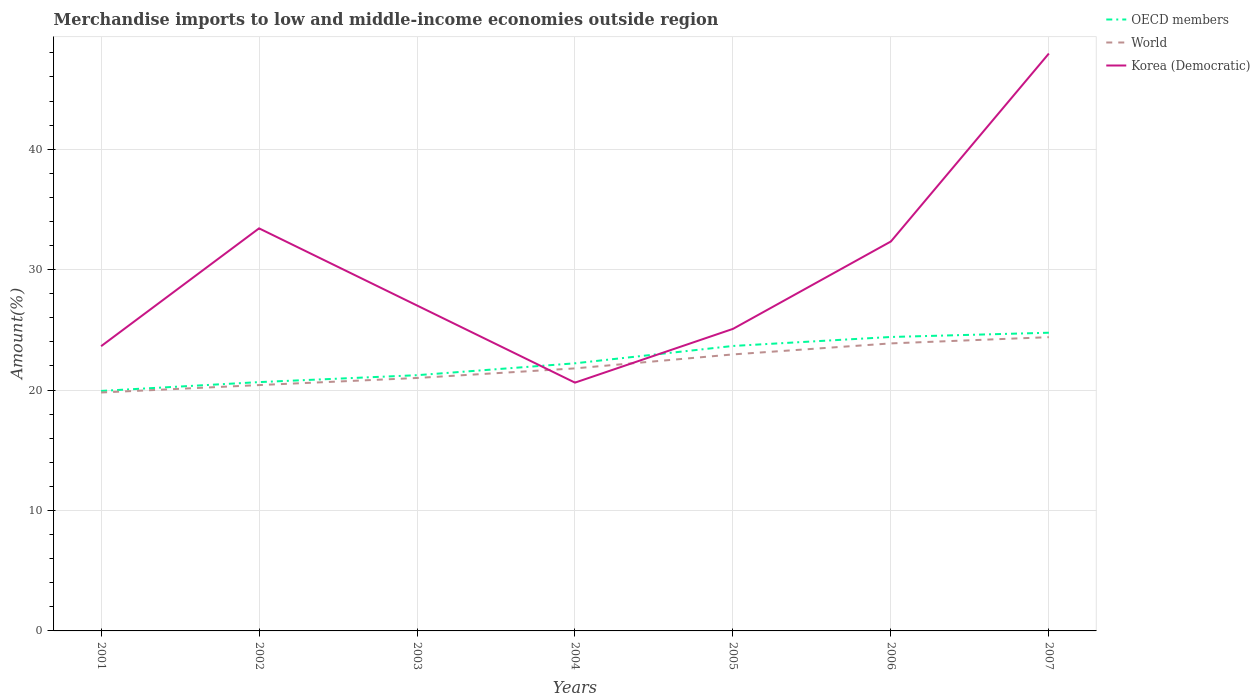How many different coloured lines are there?
Ensure brevity in your answer.  3. Across all years, what is the maximum percentage of amount earned from merchandise imports in World?
Provide a short and direct response. 19.8. In which year was the percentage of amount earned from merchandise imports in World maximum?
Ensure brevity in your answer.  2001. What is the total percentage of amount earned from merchandise imports in World in the graph?
Provide a short and direct response. -2.08. What is the difference between the highest and the second highest percentage of amount earned from merchandise imports in World?
Your response must be concise. 4.59. How many lines are there?
Your answer should be very brief. 3. What is the difference between two consecutive major ticks on the Y-axis?
Your answer should be compact. 10. Does the graph contain grids?
Provide a short and direct response. Yes. How are the legend labels stacked?
Give a very brief answer. Vertical. What is the title of the graph?
Your answer should be compact. Merchandise imports to low and middle-income economies outside region. Does "Palau" appear as one of the legend labels in the graph?
Offer a very short reply. No. What is the label or title of the X-axis?
Your response must be concise. Years. What is the label or title of the Y-axis?
Provide a succinct answer. Amount(%). What is the Amount(%) of OECD members in 2001?
Your response must be concise. 19.93. What is the Amount(%) of World in 2001?
Offer a very short reply. 19.8. What is the Amount(%) of Korea (Democratic) in 2001?
Offer a terse response. 23.64. What is the Amount(%) in OECD members in 2002?
Offer a very short reply. 20.66. What is the Amount(%) in World in 2002?
Offer a very short reply. 20.41. What is the Amount(%) of Korea (Democratic) in 2002?
Provide a succinct answer. 33.43. What is the Amount(%) of OECD members in 2003?
Your answer should be very brief. 21.23. What is the Amount(%) in World in 2003?
Your answer should be very brief. 21. What is the Amount(%) in Korea (Democratic) in 2003?
Offer a terse response. 27.02. What is the Amount(%) in OECD members in 2004?
Your answer should be compact. 22.22. What is the Amount(%) of World in 2004?
Make the answer very short. 21.8. What is the Amount(%) of Korea (Democratic) in 2004?
Give a very brief answer. 20.62. What is the Amount(%) of OECD members in 2005?
Keep it short and to the point. 23.66. What is the Amount(%) in World in 2005?
Your answer should be very brief. 22.96. What is the Amount(%) of Korea (Democratic) in 2005?
Keep it short and to the point. 25.08. What is the Amount(%) of OECD members in 2006?
Provide a succinct answer. 24.41. What is the Amount(%) in World in 2006?
Offer a terse response. 23.88. What is the Amount(%) in Korea (Democratic) in 2006?
Your answer should be very brief. 32.34. What is the Amount(%) of OECD members in 2007?
Provide a short and direct response. 24.76. What is the Amount(%) of World in 2007?
Offer a terse response. 24.39. What is the Amount(%) in Korea (Democratic) in 2007?
Ensure brevity in your answer.  47.94. Across all years, what is the maximum Amount(%) in OECD members?
Make the answer very short. 24.76. Across all years, what is the maximum Amount(%) of World?
Ensure brevity in your answer.  24.39. Across all years, what is the maximum Amount(%) of Korea (Democratic)?
Keep it short and to the point. 47.94. Across all years, what is the minimum Amount(%) of OECD members?
Offer a very short reply. 19.93. Across all years, what is the minimum Amount(%) in World?
Keep it short and to the point. 19.8. Across all years, what is the minimum Amount(%) in Korea (Democratic)?
Make the answer very short. 20.62. What is the total Amount(%) in OECD members in the graph?
Provide a short and direct response. 156.88. What is the total Amount(%) of World in the graph?
Provide a succinct answer. 154.24. What is the total Amount(%) of Korea (Democratic) in the graph?
Your answer should be compact. 210.07. What is the difference between the Amount(%) in OECD members in 2001 and that in 2002?
Your answer should be very brief. -0.73. What is the difference between the Amount(%) of World in 2001 and that in 2002?
Give a very brief answer. -0.62. What is the difference between the Amount(%) in Korea (Democratic) in 2001 and that in 2002?
Ensure brevity in your answer.  -9.79. What is the difference between the Amount(%) of OECD members in 2001 and that in 2003?
Give a very brief answer. -1.31. What is the difference between the Amount(%) in World in 2001 and that in 2003?
Your answer should be compact. -1.21. What is the difference between the Amount(%) of Korea (Democratic) in 2001 and that in 2003?
Give a very brief answer. -3.38. What is the difference between the Amount(%) of OECD members in 2001 and that in 2004?
Ensure brevity in your answer.  -2.29. What is the difference between the Amount(%) of World in 2001 and that in 2004?
Offer a terse response. -2. What is the difference between the Amount(%) of Korea (Democratic) in 2001 and that in 2004?
Offer a very short reply. 3.03. What is the difference between the Amount(%) of OECD members in 2001 and that in 2005?
Make the answer very short. -3.73. What is the difference between the Amount(%) in World in 2001 and that in 2005?
Provide a short and direct response. -3.16. What is the difference between the Amount(%) in Korea (Democratic) in 2001 and that in 2005?
Your response must be concise. -1.44. What is the difference between the Amount(%) in OECD members in 2001 and that in 2006?
Provide a short and direct response. -4.48. What is the difference between the Amount(%) in World in 2001 and that in 2006?
Ensure brevity in your answer.  -4.08. What is the difference between the Amount(%) of Korea (Democratic) in 2001 and that in 2006?
Offer a terse response. -8.7. What is the difference between the Amount(%) in OECD members in 2001 and that in 2007?
Keep it short and to the point. -4.83. What is the difference between the Amount(%) of World in 2001 and that in 2007?
Make the answer very short. -4.59. What is the difference between the Amount(%) in Korea (Democratic) in 2001 and that in 2007?
Provide a short and direct response. -24.3. What is the difference between the Amount(%) of OECD members in 2002 and that in 2003?
Your response must be concise. -0.57. What is the difference between the Amount(%) of World in 2002 and that in 2003?
Your answer should be very brief. -0.59. What is the difference between the Amount(%) in Korea (Democratic) in 2002 and that in 2003?
Offer a terse response. 6.41. What is the difference between the Amount(%) in OECD members in 2002 and that in 2004?
Give a very brief answer. -1.56. What is the difference between the Amount(%) in World in 2002 and that in 2004?
Make the answer very short. -1.39. What is the difference between the Amount(%) in Korea (Democratic) in 2002 and that in 2004?
Your response must be concise. 12.81. What is the difference between the Amount(%) of OECD members in 2002 and that in 2005?
Ensure brevity in your answer.  -3. What is the difference between the Amount(%) of World in 2002 and that in 2005?
Ensure brevity in your answer.  -2.55. What is the difference between the Amount(%) of Korea (Democratic) in 2002 and that in 2005?
Provide a short and direct response. 8.35. What is the difference between the Amount(%) of OECD members in 2002 and that in 2006?
Offer a very short reply. -3.75. What is the difference between the Amount(%) in World in 2002 and that in 2006?
Give a very brief answer. -3.46. What is the difference between the Amount(%) of Korea (Democratic) in 2002 and that in 2006?
Keep it short and to the point. 1.09. What is the difference between the Amount(%) of OECD members in 2002 and that in 2007?
Your response must be concise. -4.1. What is the difference between the Amount(%) of World in 2002 and that in 2007?
Keep it short and to the point. -3.98. What is the difference between the Amount(%) in Korea (Democratic) in 2002 and that in 2007?
Your answer should be compact. -14.52. What is the difference between the Amount(%) of OECD members in 2003 and that in 2004?
Offer a terse response. -0.99. What is the difference between the Amount(%) in World in 2003 and that in 2004?
Your answer should be very brief. -0.8. What is the difference between the Amount(%) in Korea (Democratic) in 2003 and that in 2004?
Your answer should be very brief. 6.41. What is the difference between the Amount(%) in OECD members in 2003 and that in 2005?
Keep it short and to the point. -2.43. What is the difference between the Amount(%) of World in 2003 and that in 2005?
Provide a short and direct response. -1.96. What is the difference between the Amount(%) in Korea (Democratic) in 2003 and that in 2005?
Offer a very short reply. 1.94. What is the difference between the Amount(%) of OECD members in 2003 and that in 2006?
Ensure brevity in your answer.  -3.17. What is the difference between the Amount(%) of World in 2003 and that in 2006?
Provide a succinct answer. -2.87. What is the difference between the Amount(%) in Korea (Democratic) in 2003 and that in 2006?
Your answer should be compact. -5.32. What is the difference between the Amount(%) of OECD members in 2003 and that in 2007?
Provide a short and direct response. -3.53. What is the difference between the Amount(%) in World in 2003 and that in 2007?
Provide a short and direct response. -3.39. What is the difference between the Amount(%) of Korea (Democratic) in 2003 and that in 2007?
Provide a short and direct response. -20.92. What is the difference between the Amount(%) in OECD members in 2004 and that in 2005?
Your answer should be compact. -1.44. What is the difference between the Amount(%) in World in 2004 and that in 2005?
Keep it short and to the point. -1.16. What is the difference between the Amount(%) of Korea (Democratic) in 2004 and that in 2005?
Your answer should be very brief. -4.46. What is the difference between the Amount(%) in OECD members in 2004 and that in 2006?
Keep it short and to the point. -2.19. What is the difference between the Amount(%) of World in 2004 and that in 2006?
Provide a short and direct response. -2.08. What is the difference between the Amount(%) in Korea (Democratic) in 2004 and that in 2006?
Offer a terse response. -11.72. What is the difference between the Amount(%) in OECD members in 2004 and that in 2007?
Your answer should be very brief. -2.54. What is the difference between the Amount(%) of World in 2004 and that in 2007?
Provide a succinct answer. -2.59. What is the difference between the Amount(%) of Korea (Democratic) in 2004 and that in 2007?
Ensure brevity in your answer.  -27.33. What is the difference between the Amount(%) in OECD members in 2005 and that in 2006?
Offer a terse response. -0.75. What is the difference between the Amount(%) of World in 2005 and that in 2006?
Your answer should be very brief. -0.92. What is the difference between the Amount(%) in Korea (Democratic) in 2005 and that in 2006?
Your answer should be very brief. -7.26. What is the difference between the Amount(%) in OECD members in 2005 and that in 2007?
Provide a short and direct response. -1.1. What is the difference between the Amount(%) in World in 2005 and that in 2007?
Keep it short and to the point. -1.43. What is the difference between the Amount(%) of Korea (Democratic) in 2005 and that in 2007?
Make the answer very short. -22.86. What is the difference between the Amount(%) in OECD members in 2006 and that in 2007?
Offer a very short reply. -0.35. What is the difference between the Amount(%) in World in 2006 and that in 2007?
Your response must be concise. -0.52. What is the difference between the Amount(%) of Korea (Democratic) in 2006 and that in 2007?
Ensure brevity in your answer.  -15.6. What is the difference between the Amount(%) of OECD members in 2001 and the Amount(%) of World in 2002?
Offer a very short reply. -0.49. What is the difference between the Amount(%) of OECD members in 2001 and the Amount(%) of Korea (Democratic) in 2002?
Your answer should be very brief. -13.5. What is the difference between the Amount(%) in World in 2001 and the Amount(%) in Korea (Democratic) in 2002?
Offer a terse response. -13.63. What is the difference between the Amount(%) in OECD members in 2001 and the Amount(%) in World in 2003?
Provide a short and direct response. -1.08. What is the difference between the Amount(%) in OECD members in 2001 and the Amount(%) in Korea (Democratic) in 2003?
Your response must be concise. -7.09. What is the difference between the Amount(%) of World in 2001 and the Amount(%) of Korea (Democratic) in 2003?
Provide a succinct answer. -7.22. What is the difference between the Amount(%) in OECD members in 2001 and the Amount(%) in World in 2004?
Keep it short and to the point. -1.87. What is the difference between the Amount(%) of OECD members in 2001 and the Amount(%) of Korea (Democratic) in 2004?
Give a very brief answer. -0.69. What is the difference between the Amount(%) in World in 2001 and the Amount(%) in Korea (Democratic) in 2004?
Keep it short and to the point. -0.82. What is the difference between the Amount(%) in OECD members in 2001 and the Amount(%) in World in 2005?
Offer a terse response. -3.03. What is the difference between the Amount(%) of OECD members in 2001 and the Amount(%) of Korea (Democratic) in 2005?
Offer a very short reply. -5.15. What is the difference between the Amount(%) in World in 2001 and the Amount(%) in Korea (Democratic) in 2005?
Offer a very short reply. -5.28. What is the difference between the Amount(%) in OECD members in 2001 and the Amount(%) in World in 2006?
Ensure brevity in your answer.  -3.95. What is the difference between the Amount(%) in OECD members in 2001 and the Amount(%) in Korea (Democratic) in 2006?
Offer a terse response. -12.41. What is the difference between the Amount(%) in World in 2001 and the Amount(%) in Korea (Democratic) in 2006?
Make the answer very short. -12.54. What is the difference between the Amount(%) in OECD members in 2001 and the Amount(%) in World in 2007?
Keep it short and to the point. -4.46. What is the difference between the Amount(%) of OECD members in 2001 and the Amount(%) of Korea (Democratic) in 2007?
Provide a short and direct response. -28.02. What is the difference between the Amount(%) of World in 2001 and the Amount(%) of Korea (Democratic) in 2007?
Provide a succinct answer. -28.15. What is the difference between the Amount(%) of OECD members in 2002 and the Amount(%) of World in 2003?
Provide a succinct answer. -0.34. What is the difference between the Amount(%) in OECD members in 2002 and the Amount(%) in Korea (Democratic) in 2003?
Keep it short and to the point. -6.36. What is the difference between the Amount(%) of World in 2002 and the Amount(%) of Korea (Democratic) in 2003?
Provide a succinct answer. -6.61. What is the difference between the Amount(%) of OECD members in 2002 and the Amount(%) of World in 2004?
Your answer should be very brief. -1.14. What is the difference between the Amount(%) of OECD members in 2002 and the Amount(%) of Korea (Democratic) in 2004?
Give a very brief answer. 0.04. What is the difference between the Amount(%) of World in 2002 and the Amount(%) of Korea (Democratic) in 2004?
Provide a short and direct response. -0.2. What is the difference between the Amount(%) in OECD members in 2002 and the Amount(%) in World in 2005?
Make the answer very short. -2.3. What is the difference between the Amount(%) of OECD members in 2002 and the Amount(%) of Korea (Democratic) in 2005?
Your answer should be compact. -4.42. What is the difference between the Amount(%) in World in 2002 and the Amount(%) in Korea (Democratic) in 2005?
Your response must be concise. -4.67. What is the difference between the Amount(%) of OECD members in 2002 and the Amount(%) of World in 2006?
Offer a very short reply. -3.21. What is the difference between the Amount(%) of OECD members in 2002 and the Amount(%) of Korea (Democratic) in 2006?
Offer a terse response. -11.68. What is the difference between the Amount(%) of World in 2002 and the Amount(%) of Korea (Democratic) in 2006?
Offer a terse response. -11.93. What is the difference between the Amount(%) of OECD members in 2002 and the Amount(%) of World in 2007?
Provide a succinct answer. -3.73. What is the difference between the Amount(%) in OECD members in 2002 and the Amount(%) in Korea (Democratic) in 2007?
Ensure brevity in your answer.  -27.28. What is the difference between the Amount(%) of World in 2002 and the Amount(%) of Korea (Democratic) in 2007?
Offer a very short reply. -27.53. What is the difference between the Amount(%) in OECD members in 2003 and the Amount(%) in World in 2004?
Your answer should be very brief. -0.56. What is the difference between the Amount(%) of OECD members in 2003 and the Amount(%) of Korea (Democratic) in 2004?
Offer a terse response. 0.62. What is the difference between the Amount(%) in World in 2003 and the Amount(%) in Korea (Democratic) in 2004?
Your answer should be compact. 0.39. What is the difference between the Amount(%) in OECD members in 2003 and the Amount(%) in World in 2005?
Give a very brief answer. -1.73. What is the difference between the Amount(%) in OECD members in 2003 and the Amount(%) in Korea (Democratic) in 2005?
Offer a very short reply. -3.84. What is the difference between the Amount(%) in World in 2003 and the Amount(%) in Korea (Democratic) in 2005?
Give a very brief answer. -4.08. What is the difference between the Amount(%) in OECD members in 2003 and the Amount(%) in World in 2006?
Offer a very short reply. -2.64. What is the difference between the Amount(%) in OECD members in 2003 and the Amount(%) in Korea (Democratic) in 2006?
Give a very brief answer. -11.11. What is the difference between the Amount(%) in World in 2003 and the Amount(%) in Korea (Democratic) in 2006?
Ensure brevity in your answer.  -11.34. What is the difference between the Amount(%) of OECD members in 2003 and the Amount(%) of World in 2007?
Offer a terse response. -3.16. What is the difference between the Amount(%) in OECD members in 2003 and the Amount(%) in Korea (Democratic) in 2007?
Make the answer very short. -26.71. What is the difference between the Amount(%) in World in 2003 and the Amount(%) in Korea (Democratic) in 2007?
Ensure brevity in your answer.  -26.94. What is the difference between the Amount(%) of OECD members in 2004 and the Amount(%) of World in 2005?
Provide a succinct answer. -0.74. What is the difference between the Amount(%) of OECD members in 2004 and the Amount(%) of Korea (Democratic) in 2005?
Ensure brevity in your answer.  -2.86. What is the difference between the Amount(%) in World in 2004 and the Amount(%) in Korea (Democratic) in 2005?
Your answer should be very brief. -3.28. What is the difference between the Amount(%) in OECD members in 2004 and the Amount(%) in World in 2006?
Provide a short and direct response. -1.65. What is the difference between the Amount(%) in OECD members in 2004 and the Amount(%) in Korea (Democratic) in 2006?
Your answer should be very brief. -10.12. What is the difference between the Amount(%) in World in 2004 and the Amount(%) in Korea (Democratic) in 2006?
Provide a short and direct response. -10.54. What is the difference between the Amount(%) in OECD members in 2004 and the Amount(%) in World in 2007?
Make the answer very short. -2.17. What is the difference between the Amount(%) in OECD members in 2004 and the Amount(%) in Korea (Democratic) in 2007?
Your answer should be very brief. -25.72. What is the difference between the Amount(%) in World in 2004 and the Amount(%) in Korea (Democratic) in 2007?
Give a very brief answer. -26.14. What is the difference between the Amount(%) in OECD members in 2005 and the Amount(%) in World in 2006?
Make the answer very short. -0.21. What is the difference between the Amount(%) in OECD members in 2005 and the Amount(%) in Korea (Democratic) in 2006?
Offer a very short reply. -8.68. What is the difference between the Amount(%) in World in 2005 and the Amount(%) in Korea (Democratic) in 2006?
Your answer should be very brief. -9.38. What is the difference between the Amount(%) of OECD members in 2005 and the Amount(%) of World in 2007?
Your response must be concise. -0.73. What is the difference between the Amount(%) in OECD members in 2005 and the Amount(%) in Korea (Democratic) in 2007?
Keep it short and to the point. -24.28. What is the difference between the Amount(%) in World in 2005 and the Amount(%) in Korea (Democratic) in 2007?
Make the answer very short. -24.98. What is the difference between the Amount(%) of OECD members in 2006 and the Amount(%) of World in 2007?
Offer a very short reply. 0.02. What is the difference between the Amount(%) in OECD members in 2006 and the Amount(%) in Korea (Democratic) in 2007?
Your answer should be very brief. -23.54. What is the difference between the Amount(%) in World in 2006 and the Amount(%) in Korea (Democratic) in 2007?
Provide a short and direct response. -24.07. What is the average Amount(%) of OECD members per year?
Offer a very short reply. 22.41. What is the average Amount(%) of World per year?
Your answer should be very brief. 22.03. What is the average Amount(%) of Korea (Democratic) per year?
Keep it short and to the point. 30.01. In the year 2001, what is the difference between the Amount(%) of OECD members and Amount(%) of World?
Provide a succinct answer. 0.13. In the year 2001, what is the difference between the Amount(%) in OECD members and Amount(%) in Korea (Democratic)?
Your answer should be compact. -3.71. In the year 2001, what is the difference between the Amount(%) of World and Amount(%) of Korea (Democratic)?
Provide a short and direct response. -3.84. In the year 2002, what is the difference between the Amount(%) of OECD members and Amount(%) of World?
Provide a succinct answer. 0.25. In the year 2002, what is the difference between the Amount(%) of OECD members and Amount(%) of Korea (Democratic)?
Your answer should be compact. -12.77. In the year 2002, what is the difference between the Amount(%) of World and Amount(%) of Korea (Democratic)?
Offer a very short reply. -13.01. In the year 2003, what is the difference between the Amount(%) in OECD members and Amount(%) in World?
Give a very brief answer. 0.23. In the year 2003, what is the difference between the Amount(%) of OECD members and Amount(%) of Korea (Democratic)?
Ensure brevity in your answer.  -5.79. In the year 2003, what is the difference between the Amount(%) in World and Amount(%) in Korea (Democratic)?
Offer a very short reply. -6.02. In the year 2004, what is the difference between the Amount(%) of OECD members and Amount(%) of World?
Make the answer very short. 0.42. In the year 2004, what is the difference between the Amount(%) in OECD members and Amount(%) in Korea (Democratic)?
Make the answer very short. 1.61. In the year 2004, what is the difference between the Amount(%) of World and Amount(%) of Korea (Democratic)?
Your response must be concise. 1.18. In the year 2005, what is the difference between the Amount(%) of OECD members and Amount(%) of World?
Your answer should be very brief. 0.7. In the year 2005, what is the difference between the Amount(%) of OECD members and Amount(%) of Korea (Democratic)?
Ensure brevity in your answer.  -1.42. In the year 2005, what is the difference between the Amount(%) of World and Amount(%) of Korea (Democratic)?
Make the answer very short. -2.12. In the year 2006, what is the difference between the Amount(%) of OECD members and Amount(%) of World?
Offer a terse response. 0.53. In the year 2006, what is the difference between the Amount(%) in OECD members and Amount(%) in Korea (Democratic)?
Your response must be concise. -7.93. In the year 2006, what is the difference between the Amount(%) in World and Amount(%) in Korea (Democratic)?
Your answer should be compact. -8.46. In the year 2007, what is the difference between the Amount(%) of OECD members and Amount(%) of World?
Make the answer very short. 0.37. In the year 2007, what is the difference between the Amount(%) in OECD members and Amount(%) in Korea (Democratic)?
Your answer should be compact. -23.18. In the year 2007, what is the difference between the Amount(%) of World and Amount(%) of Korea (Democratic)?
Your answer should be very brief. -23.55. What is the ratio of the Amount(%) of OECD members in 2001 to that in 2002?
Your response must be concise. 0.96. What is the ratio of the Amount(%) of World in 2001 to that in 2002?
Provide a short and direct response. 0.97. What is the ratio of the Amount(%) in Korea (Democratic) in 2001 to that in 2002?
Ensure brevity in your answer.  0.71. What is the ratio of the Amount(%) in OECD members in 2001 to that in 2003?
Make the answer very short. 0.94. What is the ratio of the Amount(%) in World in 2001 to that in 2003?
Your response must be concise. 0.94. What is the ratio of the Amount(%) of Korea (Democratic) in 2001 to that in 2003?
Make the answer very short. 0.87. What is the ratio of the Amount(%) in OECD members in 2001 to that in 2004?
Offer a very short reply. 0.9. What is the ratio of the Amount(%) of World in 2001 to that in 2004?
Offer a terse response. 0.91. What is the ratio of the Amount(%) in Korea (Democratic) in 2001 to that in 2004?
Your answer should be compact. 1.15. What is the ratio of the Amount(%) of OECD members in 2001 to that in 2005?
Offer a terse response. 0.84. What is the ratio of the Amount(%) of World in 2001 to that in 2005?
Provide a short and direct response. 0.86. What is the ratio of the Amount(%) in Korea (Democratic) in 2001 to that in 2005?
Make the answer very short. 0.94. What is the ratio of the Amount(%) in OECD members in 2001 to that in 2006?
Give a very brief answer. 0.82. What is the ratio of the Amount(%) in World in 2001 to that in 2006?
Your answer should be compact. 0.83. What is the ratio of the Amount(%) of Korea (Democratic) in 2001 to that in 2006?
Give a very brief answer. 0.73. What is the ratio of the Amount(%) in OECD members in 2001 to that in 2007?
Your answer should be very brief. 0.8. What is the ratio of the Amount(%) of World in 2001 to that in 2007?
Keep it short and to the point. 0.81. What is the ratio of the Amount(%) of Korea (Democratic) in 2001 to that in 2007?
Your answer should be very brief. 0.49. What is the ratio of the Amount(%) in World in 2002 to that in 2003?
Provide a short and direct response. 0.97. What is the ratio of the Amount(%) of Korea (Democratic) in 2002 to that in 2003?
Give a very brief answer. 1.24. What is the ratio of the Amount(%) in OECD members in 2002 to that in 2004?
Your answer should be compact. 0.93. What is the ratio of the Amount(%) of World in 2002 to that in 2004?
Ensure brevity in your answer.  0.94. What is the ratio of the Amount(%) in Korea (Democratic) in 2002 to that in 2004?
Offer a terse response. 1.62. What is the ratio of the Amount(%) in OECD members in 2002 to that in 2005?
Keep it short and to the point. 0.87. What is the ratio of the Amount(%) in World in 2002 to that in 2005?
Give a very brief answer. 0.89. What is the ratio of the Amount(%) of Korea (Democratic) in 2002 to that in 2005?
Make the answer very short. 1.33. What is the ratio of the Amount(%) in OECD members in 2002 to that in 2006?
Your answer should be compact. 0.85. What is the ratio of the Amount(%) in World in 2002 to that in 2006?
Your answer should be compact. 0.85. What is the ratio of the Amount(%) of Korea (Democratic) in 2002 to that in 2006?
Keep it short and to the point. 1.03. What is the ratio of the Amount(%) in OECD members in 2002 to that in 2007?
Offer a very short reply. 0.83. What is the ratio of the Amount(%) of World in 2002 to that in 2007?
Make the answer very short. 0.84. What is the ratio of the Amount(%) in Korea (Democratic) in 2002 to that in 2007?
Offer a terse response. 0.7. What is the ratio of the Amount(%) in OECD members in 2003 to that in 2004?
Offer a very short reply. 0.96. What is the ratio of the Amount(%) in World in 2003 to that in 2004?
Offer a very short reply. 0.96. What is the ratio of the Amount(%) in Korea (Democratic) in 2003 to that in 2004?
Your answer should be compact. 1.31. What is the ratio of the Amount(%) of OECD members in 2003 to that in 2005?
Your answer should be compact. 0.9. What is the ratio of the Amount(%) in World in 2003 to that in 2005?
Your answer should be very brief. 0.91. What is the ratio of the Amount(%) in Korea (Democratic) in 2003 to that in 2005?
Make the answer very short. 1.08. What is the ratio of the Amount(%) in OECD members in 2003 to that in 2006?
Your answer should be compact. 0.87. What is the ratio of the Amount(%) in World in 2003 to that in 2006?
Ensure brevity in your answer.  0.88. What is the ratio of the Amount(%) of Korea (Democratic) in 2003 to that in 2006?
Give a very brief answer. 0.84. What is the ratio of the Amount(%) in OECD members in 2003 to that in 2007?
Give a very brief answer. 0.86. What is the ratio of the Amount(%) of World in 2003 to that in 2007?
Give a very brief answer. 0.86. What is the ratio of the Amount(%) in Korea (Democratic) in 2003 to that in 2007?
Offer a terse response. 0.56. What is the ratio of the Amount(%) of OECD members in 2004 to that in 2005?
Ensure brevity in your answer.  0.94. What is the ratio of the Amount(%) of World in 2004 to that in 2005?
Make the answer very short. 0.95. What is the ratio of the Amount(%) of Korea (Democratic) in 2004 to that in 2005?
Make the answer very short. 0.82. What is the ratio of the Amount(%) in OECD members in 2004 to that in 2006?
Ensure brevity in your answer.  0.91. What is the ratio of the Amount(%) in World in 2004 to that in 2006?
Your answer should be very brief. 0.91. What is the ratio of the Amount(%) in Korea (Democratic) in 2004 to that in 2006?
Your answer should be very brief. 0.64. What is the ratio of the Amount(%) in OECD members in 2004 to that in 2007?
Provide a succinct answer. 0.9. What is the ratio of the Amount(%) of World in 2004 to that in 2007?
Offer a terse response. 0.89. What is the ratio of the Amount(%) in Korea (Democratic) in 2004 to that in 2007?
Your answer should be compact. 0.43. What is the ratio of the Amount(%) in OECD members in 2005 to that in 2006?
Offer a very short reply. 0.97. What is the ratio of the Amount(%) of World in 2005 to that in 2006?
Offer a very short reply. 0.96. What is the ratio of the Amount(%) of Korea (Democratic) in 2005 to that in 2006?
Keep it short and to the point. 0.78. What is the ratio of the Amount(%) in OECD members in 2005 to that in 2007?
Provide a succinct answer. 0.96. What is the ratio of the Amount(%) in World in 2005 to that in 2007?
Keep it short and to the point. 0.94. What is the ratio of the Amount(%) of Korea (Democratic) in 2005 to that in 2007?
Offer a very short reply. 0.52. What is the ratio of the Amount(%) of OECD members in 2006 to that in 2007?
Ensure brevity in your answer.  0.99. What is the ratio of the Amount(%) in World in 2006 to that in 2007?
Offer a very short reply. 0.98. What is the ratio of the Amount(%) of Korea (Democratic) in 2006 to that in 2007?
Make the answer very short. 0.67. What is the difference between the highest and the second highest Amount(%) of OECD members?
Provide a short and direct response. 0.35. What is the difference between the highest and the second highest Amount(%) of World?
Offer a very short reply. 0.52. What is the difference between the highest and the second highest Amount(%) of Korea (Democratic)?
Provide a succinct answer. 14.52. What is the difference between the highest and the lowest Amount(%) in OECD members?
Your response must be concise. 4.83. What is the difference between the highest and the lowest Amount(%) of World?
Ensure brevity in your answer.  4.59. What is the difference between the highest and the lowest Amount(%) of Korea (Democratic)?
Your answer should be very brief. 27.33. 